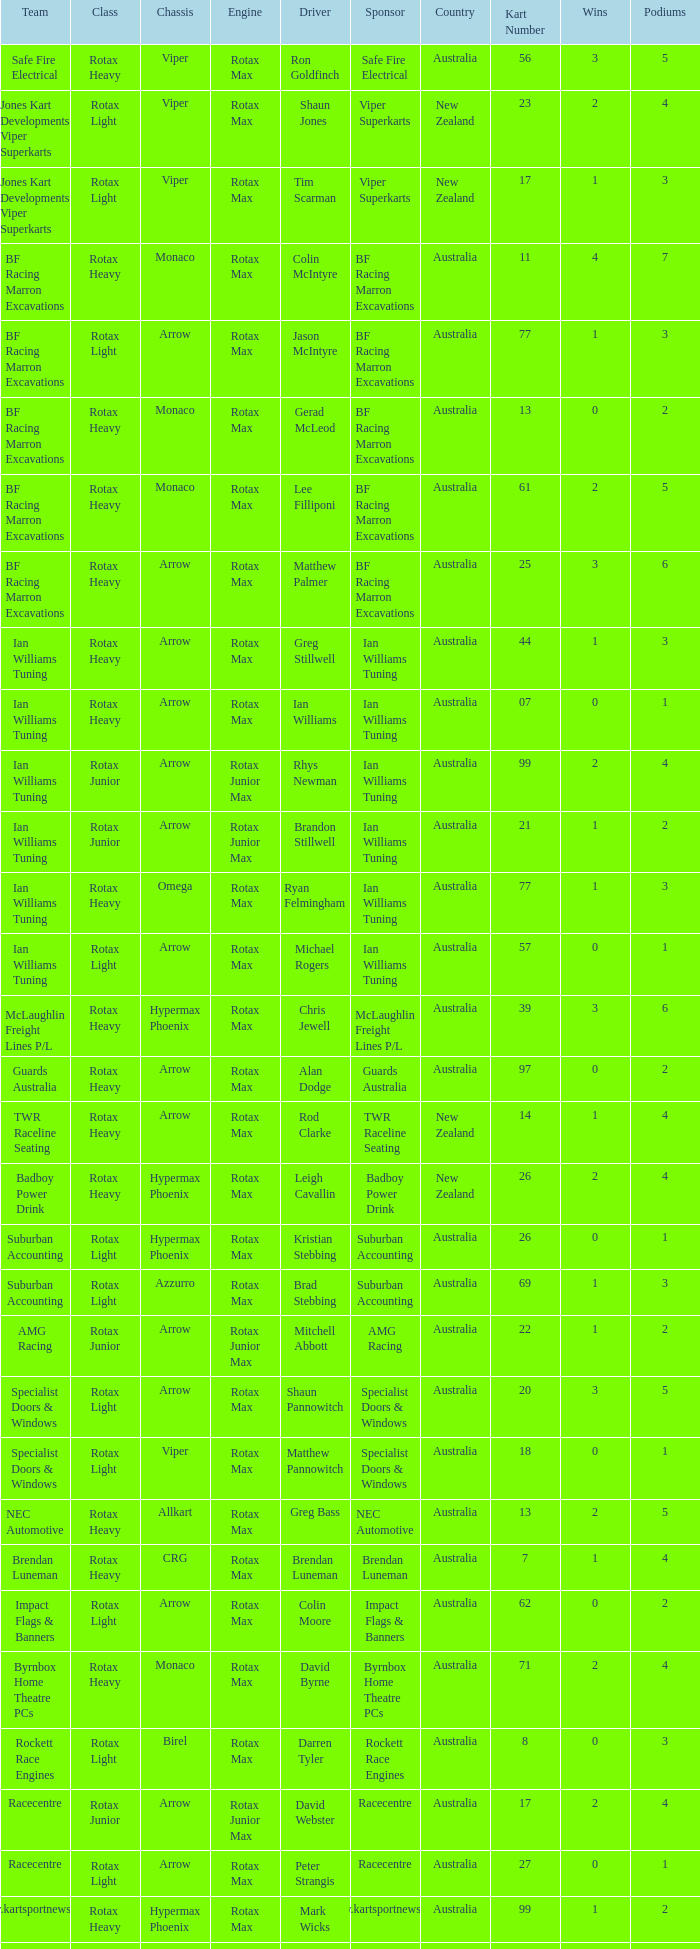What type of engine does the BF Racing Marron Excavations have that also has Monaco as chassis and Lee Filliponi as the driver? Rotax Max. 